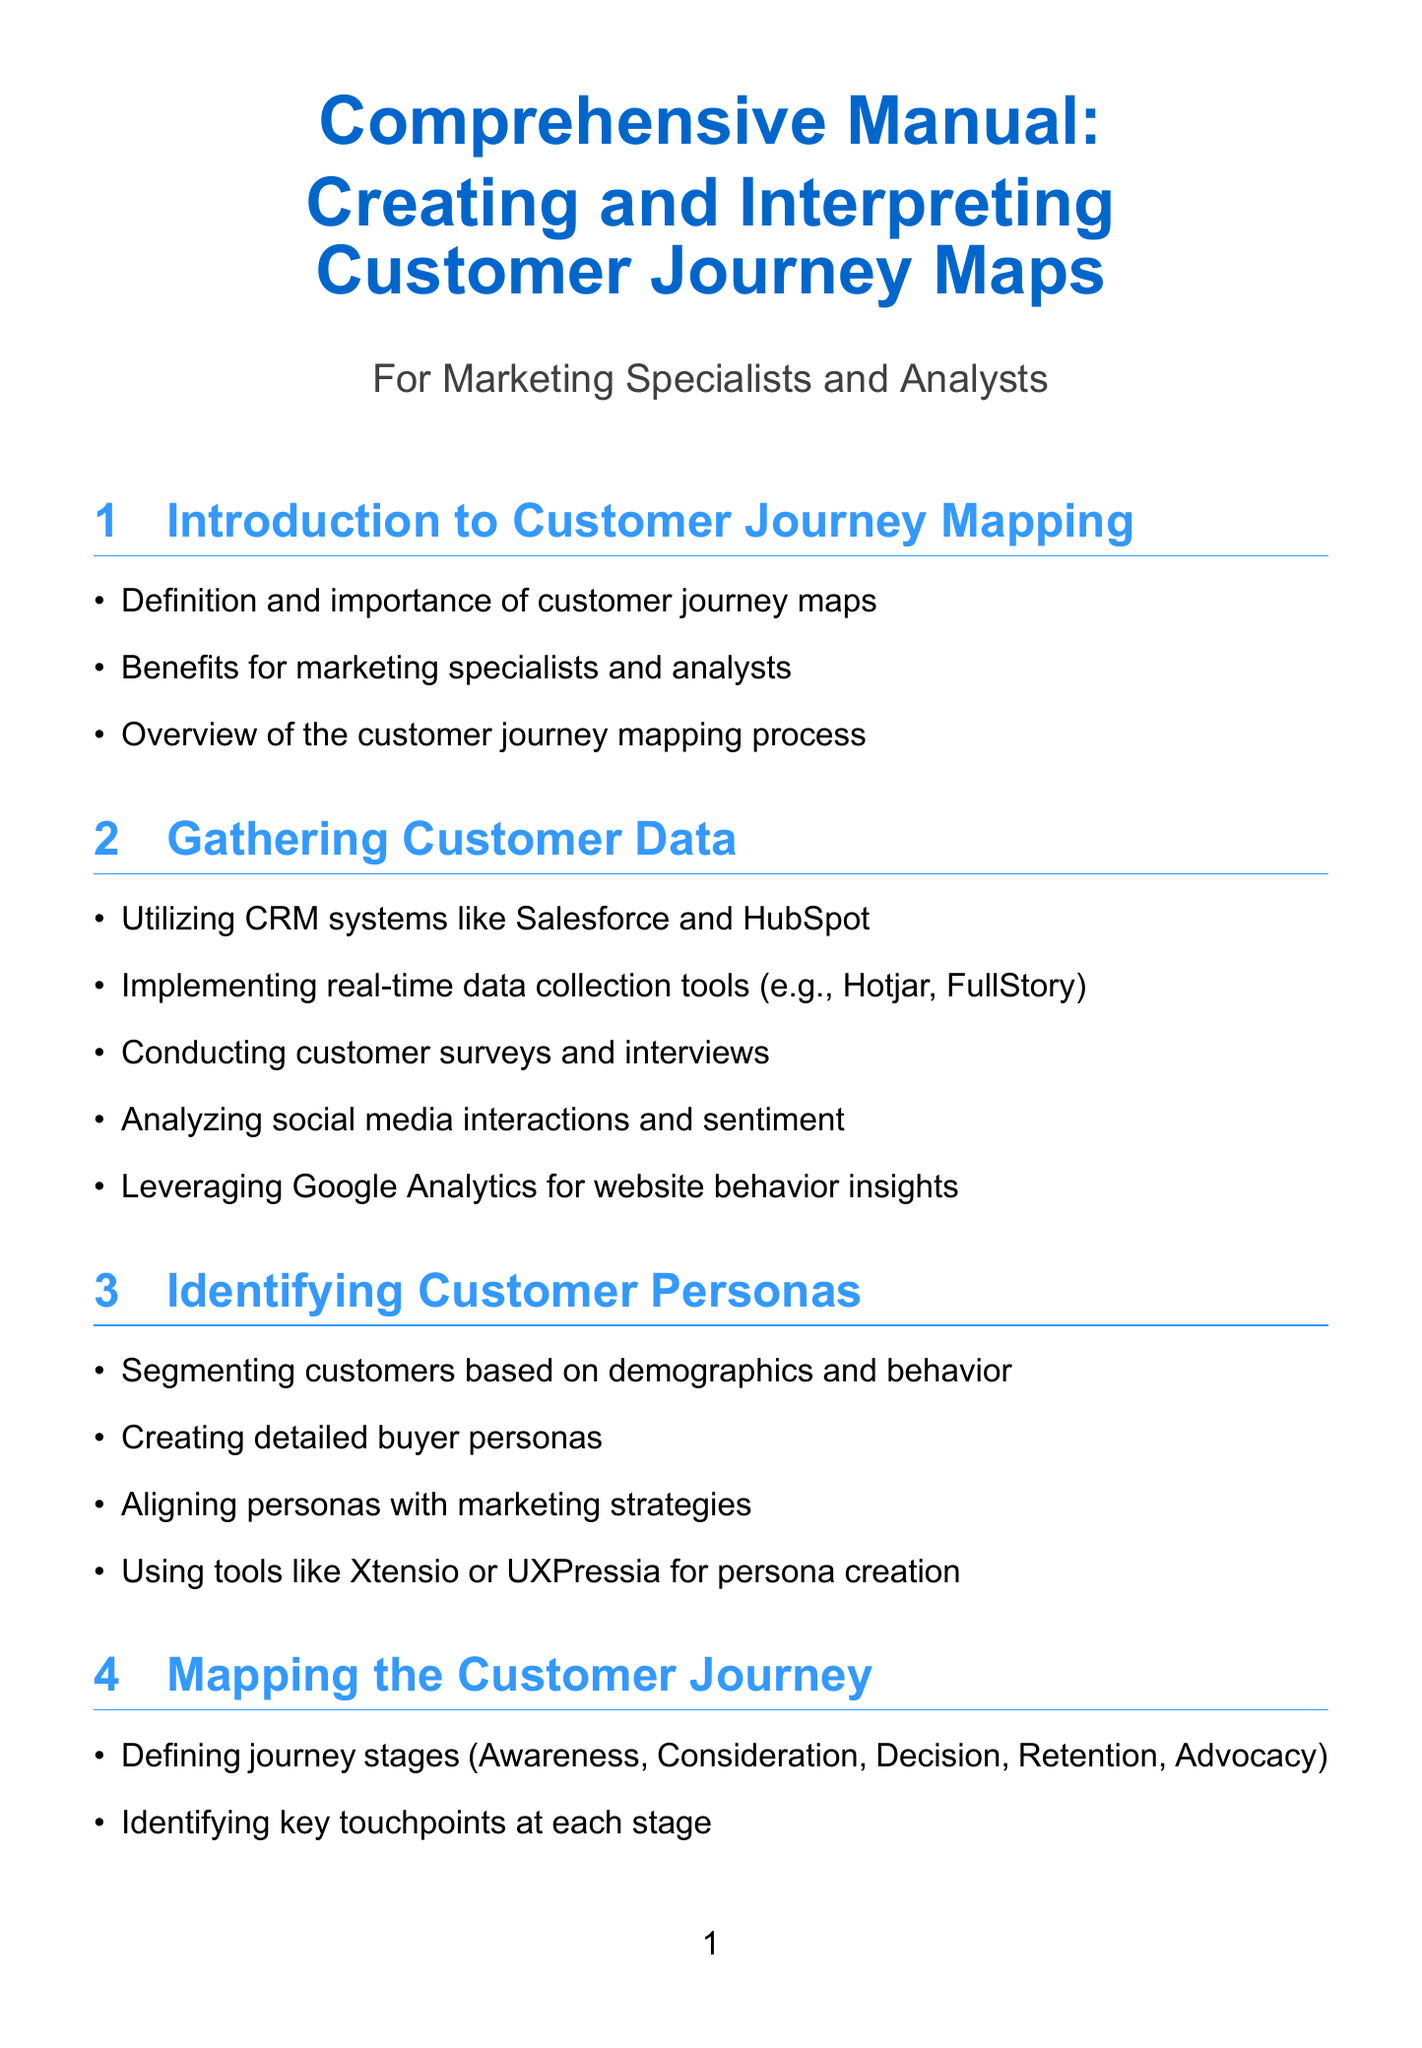What is the title of the document? The title is found at the beginning of the document, summarizing its main focus.
Answer: Comprehensive Manual: Creating and Interpreting Customer Journey Maps How many sections are included in the manual? The number of sections is a specific detail presented in the content structure of the document.
Answer: Ten Which tool is suggested for implementing real-time data collection? This is a specific tool mentioned under gathering customer data in the document.
Answer: Hotjar What is the focus of the section titled "Identifying Key Touchpoints"? The focus is described under the specific section title explaining its contents.
Answer: Analyzing customer feedback What stage comes after Consideration in the customer journey mapping process? The journey stages are sequentially listed in the mapping section of the document.
Answer: Decision Which sentiment analysis tool is mentioned in the section on uncovering pain points? This tool is identified as a resource under the pain points section content.
Answer: Brandwatch What percentage change is measured for customer satisfaction? The measurement of customer satisfaction changes is specified in the document's section on measuring impact and ROI.
Answer: Net Promoter Score Which journey mapping software is mentioned first in the tools and resources section? The first software tool listed provides an indication of the sequence in which resources are presented.
Answer: Smaply What does the ROI stand for in the context of measuring impact? This abbreviation is mentioned specifically in discussions about impact measurement.
Answer: Return on Investment What is the primary benefit of customer journey maps to marketing specialists? The benefit is highlighted in the introduction, summarizing its significance in the context provided.
Answer: Insights for decision-making 